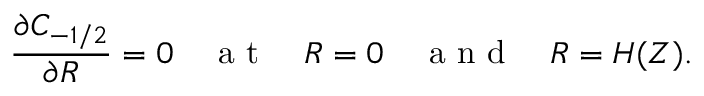<formula> <loc_0><loc_0><loc_500><loc_500>\frac { \partial C _ { - 1 / 2 } } { \partial R } = 0 \quad a t \quad R = 0 \quad a n d \quad R = H ( Z ) .</formula> 